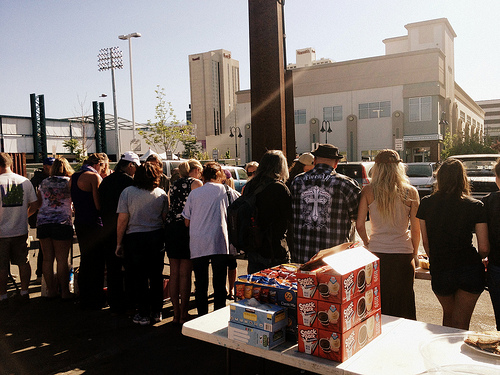<image>
Is there a pole in front of the building? Yes. The pole is positioned in front of the building, appearing closer to the camera viewpoint. 